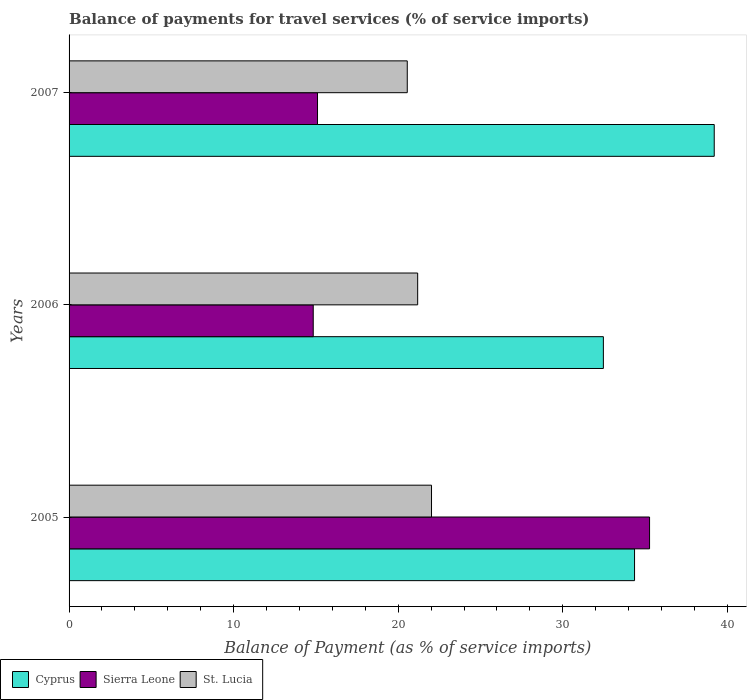How many groups of bars are there?
Give a very brief answer. 3. Are the number of bars on each tick of the Y-axis equal?
Give a very brief answer. Yes. How many bars are there on the 1st tick from the top?
Your answer should be compact. 3. How many bars are there on the 2nd tick from the bottom?
Give a very brief answer. 3. What is the label of the 3rd group of bars from the top?
Offer a very short reply. 2005. What is the balance of payments for travel services in Sierra Leone in 2006?
Make the answer very short. 14.84. Across all years, what is the maximum balance of payments for travel services in St. Lucia?
Make the answer very short. 22.02. Across all years, what is the minimum balance of payments for travel services in Sierra Leone?
Offer a terse response. 14.84. In which year was the balance of payments for travel services in Sierra Leone maximum?
Give a very brief answer. 2005. What is the total balance of payments for travel services in Cyprus in the graph?
Give a very brief answer. 106.03. What is the difference between the balance of payments for travel services in St. Lucia in 2005 and that in 2007?
Your answer should be very brief. 1.47. What is the difference between the balance of payments for travel services in Sierra Leone in 2006 and the balance of payments for travel services in St. Lucia in 2007?
Ensure brevity in your answer.  -5.71. What is the average balance of payments for travel services in Cyprus per year?
Your answer should be compact. 35.34. In the year 2006, what is the difference between the balance of payments for travel services in Cyprus and balance of payments for travel services in Sierra Leone?
Make the answer very short. 17.63. What is the ratio of the balance of payments for travel services in Sierra Leone in 2005 to that in 2007?
Offer a very short reply. 2.34. Is the balance of payments for travel services in Sierra Leone in 2005 less than that in 2006?
Your answer should be very brief. No. What is the difference between the highest and the second highest balance of payments for travel services in Sierra Leone?
Your answer should be very brief. 20.18. What is the difference between the highest and the lowest balance of payments for travel services in Cyprus?
Provide a short and direct response. 6.74. In how many years, is the balance of payments for travel services in Cyprus greater than the average balance of payments for travel services in Cyprus taken over all years?
Provide a succinct answer. 1. Is the sum of the balance of payments for travel services in St. Lucia in 2006 and 2007 greater than the maximum balance of payments for travel services in Sierra Leone across all years?
Keep it short and to the point. Yes. What does the 1st bar from the top in 2005 represents?
Make the answer very short. St. Lucia. What does the 2nd bar from the bottom in 2007 represents?
Your answer should be compact. Sierra Leone. Is it the case that in every year, the sum of the balance of payments for travel services in St. Lucia and balance of payments for travel services in Cyprus is greater than the balance of payments for travel services in Sierra Leone?
Your response must be concise. Yes. How many bars are there?
Make the answer very short. 9. How many years are there in the graph?
Your response must be concise. 3. What is the difference between two consecutive major ticks on the X-axis?
Ensure brevity in your answer.  10. Are the values on the major ticks of X-axis written in scientific E-notation?
Your answer should be very brief. No. Does the graph contain any zero values?
Give a very brief answer. No. Where does the legend appear in the graph?
Provide a succinct answer. Bottom left. How are the legend labels stacked?
Offer a very short reply. Horizontal. What is the title of the graph?
Provide a short and direct response. Balance of payments for travel services (% of service imports). What is the label or title of the X-axis?
Make the answer very short. Balance of Payment (as % of service imports). What is the Balance of Payment (as % of service imports) of Cyprus in 2005?
Provide a short and direct response. 34.36. What is the Balance of Payment (as % of service imports) of Sierra Leone in 2005?
Offer a terse response. 35.27. What is the Balance of Payment (as % of service imports) in St. Lucia in 2005?
Keep it short and to the point. 22.02. What is the Balance of Payment (as % of service imports) in Cyprus in 2006?
Ensure brevity in your answer.  32.47. What is the Balance of Payment (as % of service imports) of Sierra Leone in 2006?
Make the answer very short. 14.84. What is the Balance of Payment (as % of service imports) of St. Lucia in 2006?
Provide a short and direct response. 21.18. What is the Balance of Payment (as % of service imports) in Cyprus in 2007?
Provide a short and direct response. 39.2. What is the Balance of Payment (as % of service imports) of Sierra Leone in 2007?
Keep it short and to the point. 15.1. What is the Balance of Payment (as % of service imports) of St. Lucia in 2007?
Provide a succinct answer. 20.55. Across all years, what is the maximum Balance of Payment (as % of service imports) in Cyprus?
Make the answer very short. 39.2. Across all years, what is the maximum Balance of Payment (as % of service imports) of Sierra Leone?
Your answer should be very brief. 35.27. Across all years, what is the maximum Balance of Payment (as % of service imports) of St. Lucia?
Make the answer very short. 22.02. Across all years, what is the minimum Balance of Payment (as % of service imports) of Cyprus?
Provide a succinct answer. 32.47. Across all years, what is the minimum Balance of Payment (as % of service imports) in Sierra Leone?
Your response must be concise. 14.84. Across all years, what is the minimum Balance of Payment (as % of service imports) of St. Lucia?
Provide a succinct answer. 20.55. What is the total Balance of Payment (as % of service imports) of Cyprus in the graph?
Provide a succinct answer. 106.03. What is the total Balance of Payment (as % of service imports) of Sierra Leone in the graph?
Provide a succinct answer. 65.21. What is the total Balance of Payment (as % of service imports) of St. Lucia in the graph?
Your response must be concise. 63.76. What is the difference between the Balance of Payment (as % of service imports) in Cyprus in 2005 and that in 2006?
Provide a succinct answer. 1.89. What is the difference between the Balance of Payment (as % of service imports) in Sierra Leone in 2005 and that in 2006?
Ensure brevity in your answer.  20.44. What is the difference between the Balance of Payment (as % of service imports) of St. Lucia in 2005 and that in 2006?
Offer a very short reply. 0.84. What is the difference between the Balance of Payment (as % of service imports) of Cyprus in 2005 and that in 2007?
Provide a succinct answer. -4.84. What is the difference between the Balance of Payment (as % of service imports) in Sierra Leone in 2005 and that in 2007?
Your answer should be very brief. 20.18. What is the difference between the Balance of Payment (as % of service imports) of St. Lucia in 2005 and that in 2007?
Offer a very short reply. 1.47. What is the difference between the Balance of Payment (as % of service imports) of Cyprus in 2006 and that in 2007?
Keep it short and to the point. -6.74. What is the difference between the Balance of Payment (as % of service imports) in Sierra Leone in 2006 and that in 2007?
Ensure brevity in your answer.  -0.26. What is the difference between the Balance of Payment (as % of service imports) in St. Lucia in 2006 and that in 2007?
Your answer should be compact. 0.63. What is the difference between the Balance of Payment (as % of service imports) in Cyprus in 2005 and the Balance of Payment (as % of service imports) in Sierra Leone in 2006?
Your answer should be very brief. 19.52. What is the difference between the Balance of Payment (as % of service imports) in Cyprus in 2005 and the Balance of Payment (as % of service imports) in St. Lucia in 2006?
Make the answer very short. 13.18. What is the difference between the Balance of Payment (as % of service imports) of Sierra Leone in 2005 and the Balance of Payment (as % of service imports) of St. Lucia in 2006?
Your response must be concise. 14.09. What is the difference between the Balance of Payment (as % of service imports) of Cyprus in 2005 and the Balance of Payment (as % of service imports) of Sierra Leone in 2007?
Offer a very short reply. 19.26. What is the difference between the Balance of Payment (as % of service imports) in Cyprus in 2005 and the Balance of Payment (as % of service imports) in St. Lucia in 2007?
Give a very brief answer. 13.81. What is the difference between the Balance of Payment (as % of service imports) in Sierra Leone in 2005 and the Balance of Payment (as % of service imports) in St. Lucia in 2007?
Your answer should be compact. 14.72. What is the difference between the Balance of Payment (as % of service imports) of Cyprus in 2006 and the Balance of Payment (as % of service imports) of Sierra Leone in 2007?
Provide a short and direct response. 17.37. What is the difference between the Balance of Payment (as % of service imports) of Cyprus in 2006 and the Balance of Payment (as % of service imports) of St. Lucia in 2007?
Offer a terse response. 11.92. What is the difference between the Balance of Payment (as % of service imports) in Sierra Leone in 2006 and the Balance of Payment (as % of service imports) in St. Lucia in 2007?
Your answer should be compact. -5.71. What is the average Balance of Payment (as % of service imports) in Cyprus per year?
Offer a terse response. 35.34. What is the average Balance of Payment (as % of service imports) of Sierra Leone per year?
Your response must be concise. 21.74. What is the average Balance of Payment (as % of service imports) of St. Lucia per year?
Provide a short and direct response. 21.25. In the year 2005, what is the difference between the Balance of Payment (as % of service imports) of Cyprus and Balance of Payment (as % of service imports) of Sierra Leone?
Your answer should be compact. -0.91. In the year 2005, what is the difference between the Balance of Payment (as % of service imports) in Cyprus and Balance of Payment (as % of service imports) in St. Lucia?
Provide a short and direct response. 12.34. In the year 2005, what is the difference between the Balance of Payment (as % of service imports) in Sierra Leone and Balance of Payment (as % of service imports) in St. Lucia?
Your answer should be very brief. 13.25. In the year 2006, what is the difference between the Balance of Payment (as % of service imports) in Cyprus and Balance of Payment (as % of service imports) in Sierra Leone?
Offer a terse response. 17.63. In the year 2006, what is the difference between the Balance of Payment (as % of service imports) of Cyprus and Balance of Payment (as % of service imports) of St. Lucia?
Give a very brief answer. 11.28. In the year 2006, what is the difference between the Balance of Payment (as % of service imports) of Sierra Leone and Balance of Payment (as % of service imports) of St. Lucia?
Ensure brevity in your answer.  -6.35. In the year 2007, what is the difference between the Balance of Payment (as % of service imports) of Cyprus and Balance of Payment (as % of service imports) of Sierra Leone?
Keep it short and to the point. 24.11. In the year 2007, what is the difference between the Balance of Payment (as % of service imports) in Cyprus and Balance of Payment (as % of service imports) in St. Lucia?
Provide a succinct answer. 18.65. In the year 2007, what is the difference between the Balance of Payment (as % of service imports) of Sierra Leone and Balance of Payment (as % of service imports) of St. Lucia?
Give a very brief answer. -5.45. What is the ratio of the Balance of Payment (as % of service imports) in Cyprus in 2005 to that in 2006?
Ensure brevity in your answer.  1.06. What is the ratio of the Balance of Payment (as % of service imports) in Sierra Leone in 2005 to that in 2006?
Your answer should be very brief. 2.38. What is the ratio of the Balance of Payment (as % of service imports) in St. Lucia in 2005 to that in 2006?
Your answer should be very brief. 1.04. What is the ratio of the Balance of Payment (as % of service imports) of Cyprus in 2005 to that in 2007?
Give a very brief answer. 0.88. What is the ratio of the Balance of Payment (as % of service imports) of Sierra Leone in 2005 to that in 2007?
Your response must be concise. 2.34. What is the ratio of the Balance of Payment (as % of service imports) of St. Lucia in 2005 to that in 2007?
Your answer should be very brief. 1.07. What is the ratio of the Balance of Payment (as % of service imports) in Cyprus in 2006 to that in 2007?
Your answer should be very brief. 0.83. What is the ratio of the Balance of Payment (as % of service imports) in Sierra Leone in 2006 to that in 2007?
Give a very brief answer. 0.98. What is the ratio of the Balance of Payment (as % of service imports) in St. Lucia in 2006 to that in 2007?
Your response must be concise. 1.03. What is the difference between the highest and the second highest Balance of Payment (as % of service imports) in Cyprus?
Your response must be concise. 4.84. What is the difference between the highest and the second highest Balance of Payment (as % of service imports) in Sierra Leone?
Provide a succinct answer. 20.18. What is the difference between the highest and the second highest Balance of Payment (as % of service imports) of St. Lucia?
Provide a short and direct response. 0.84. What is the difference between the highest and the lowest Balance of Payment (as % of service imports) of Cyprus?
Your response must be concise. 6.74. What is the difference between the highest and the lowest Balance of Payment (as % of service imports) in Sierra Leone?
Make the answer very short. 20.44. What is the difference between the highest and the lowest Balance of Payment (as % of service imports) of St. Lucia?
Your answer should be very brief. 1.47. 